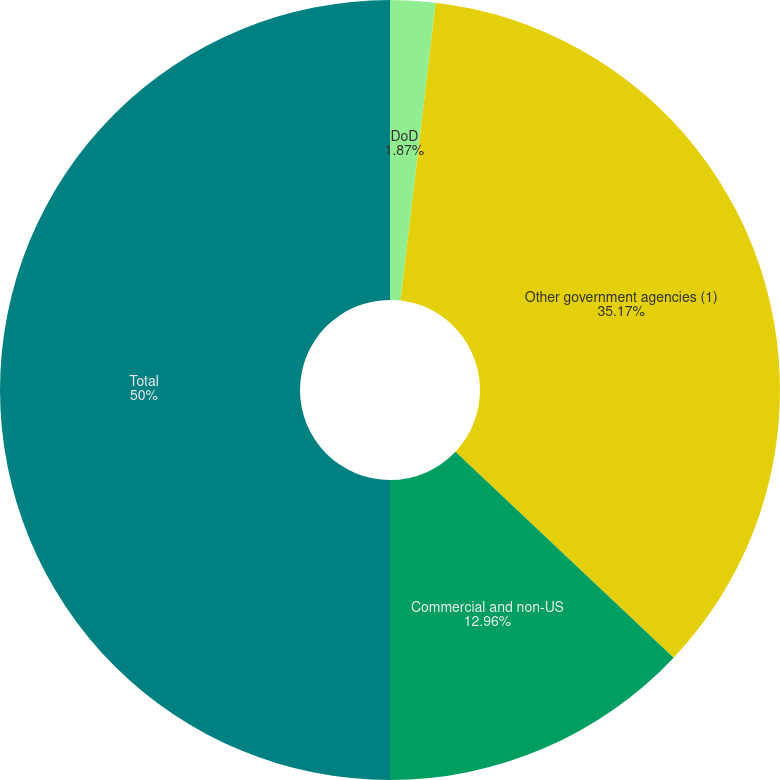Convert chart. <chart><loc_0><loc_0><loc_500><loc_500><pie_chart><fcel>DoD<fcel>Other government agencies (1)<fcel>Commercial and non-US<fcel>Total<nl><fcel>1.87%<fcel>35.17%<fcel>12.96%<fcel>50.0%<nl></chart> 